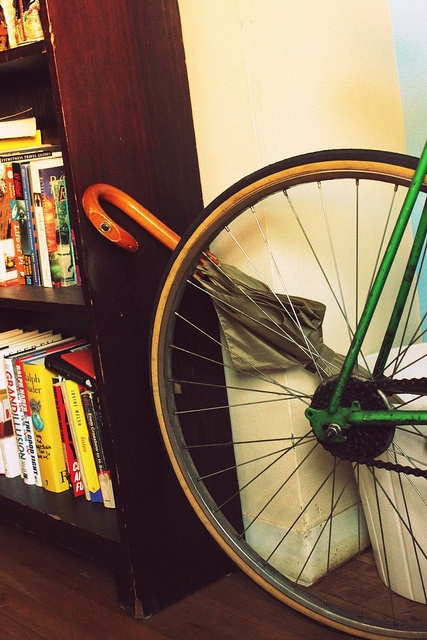Describe the objects in this image and their specific colors. I can see bicycle in khaki, black, tan, and maroon tones, umbrella in khaki, gray, black, maroon, and red tones, book in khaki, beige, black, and red tones, book in khaki, gold, orange, and olive tones, and book in khaki, gold, and tan tones in this image. 